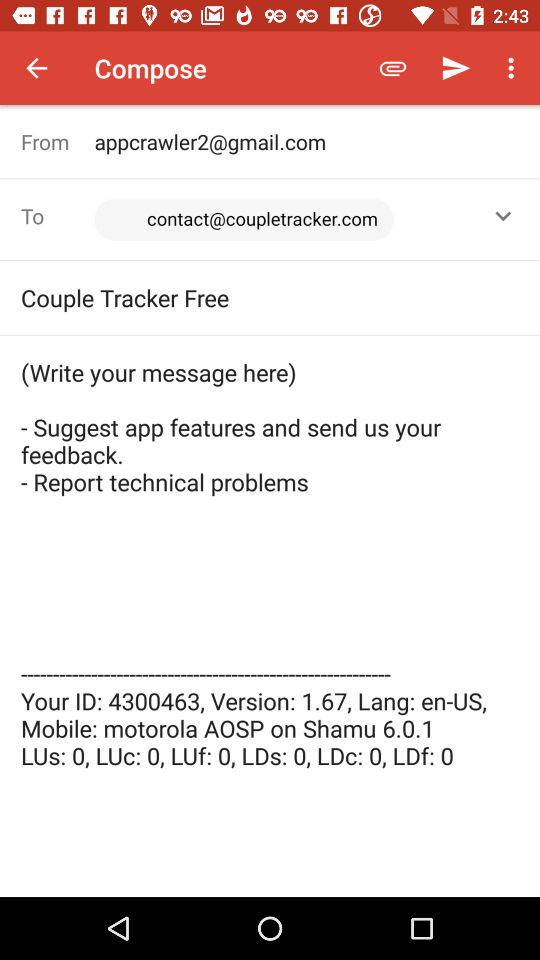What is the mobile model name? The mobile model name is "Shamu". 